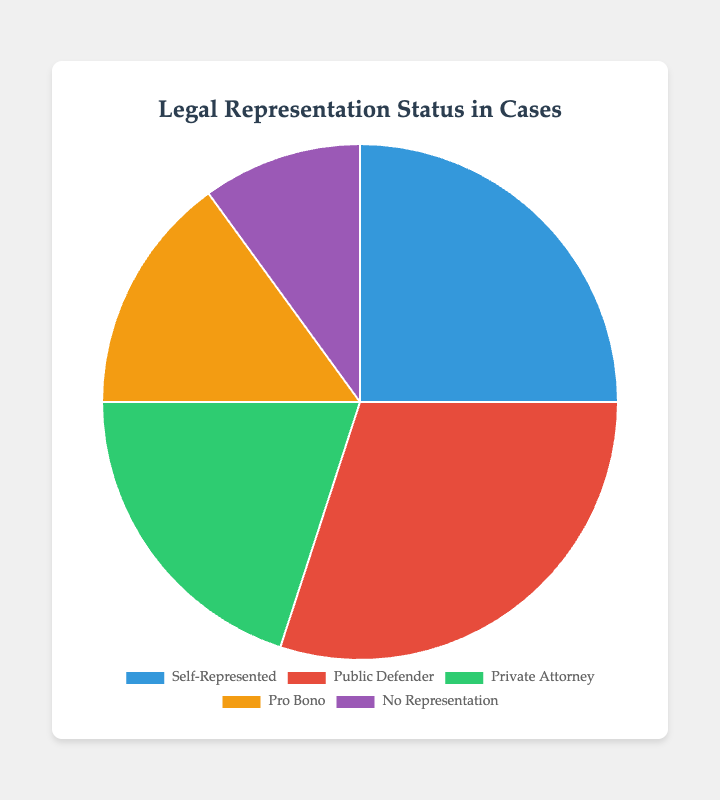What's the largest category of legal representation? Identify the category with the highest percentage in the pie chart. The "Public Defender" category has the largest percentage, 30%.
Answer: Public Defender What's the combined percentage of cases represented by Public Defender and Private Attorney? Add the percentages for "Public Defender" (30%) and "Private Attorney" (20%). 30 + 20 = 50%.
Answer: 50% Which category has the smallest representation? Identify the category with the lowest percentage in the pie chart. The "No Representation" category has the smallest percentage, 10%.
Answer: No Representation How does the percentage of Self-Represented cases compare to Pro Bono cases? Compare the percentages of "Self-Represented" (25%) and "Pro Bono" (15%). The Self-Represented percentage is greater.
Answer: Self-Represented is greater What's the total percentage of represented cases (excluding No Representation)? Add the percentages of all categories except "No Representation" (10%). 25% (Self-Represented) + 30% (Public Defender) + 20% (Private Attorney) + 15% (Pro Bono) = 90%.
Answer: 90% What is the percentage difference between cases with Private Attorney and Pro Bono representation? Subtract the percentage of "Pro Bono" (15%) from "Private Attorney" (20%). 20 - 15 = 5%.
Answer: 5% Are there more Self-Represented cases or No Representation cases? Compare the percentages of "Self-Represented" (25%) and "No Representation" (10%). The percentage of Self-Represented cases is higher.
Answer: Self-Represented What color represents Public Defender cases in the pie chart? The color associated with "Public Defender" in the pie chart is red.
Answer: Red What's the difference in percentages between Public Defender and Self-Represented cases? Subtract the percentage of "Self-Represented" (25%) from "Public Defender" (30%). 30 - 25 = 5%.
Answer: 5% 